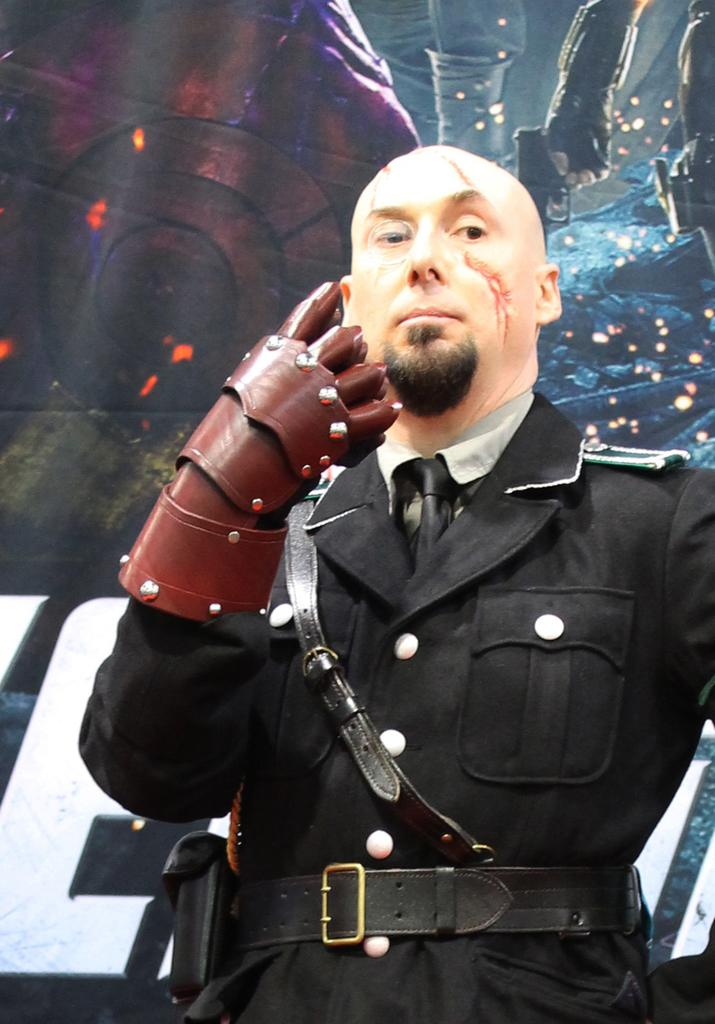What is the main subject of the image? There is a man standing in the image. Can you describe the man's attire or accessories? The man has a glove on one of his hands. What can be seen in the background of the image? There is a hoarding in the background of the image. What type of noise is the man making in the image? There is no indication of any noise being made by the man in the image. 